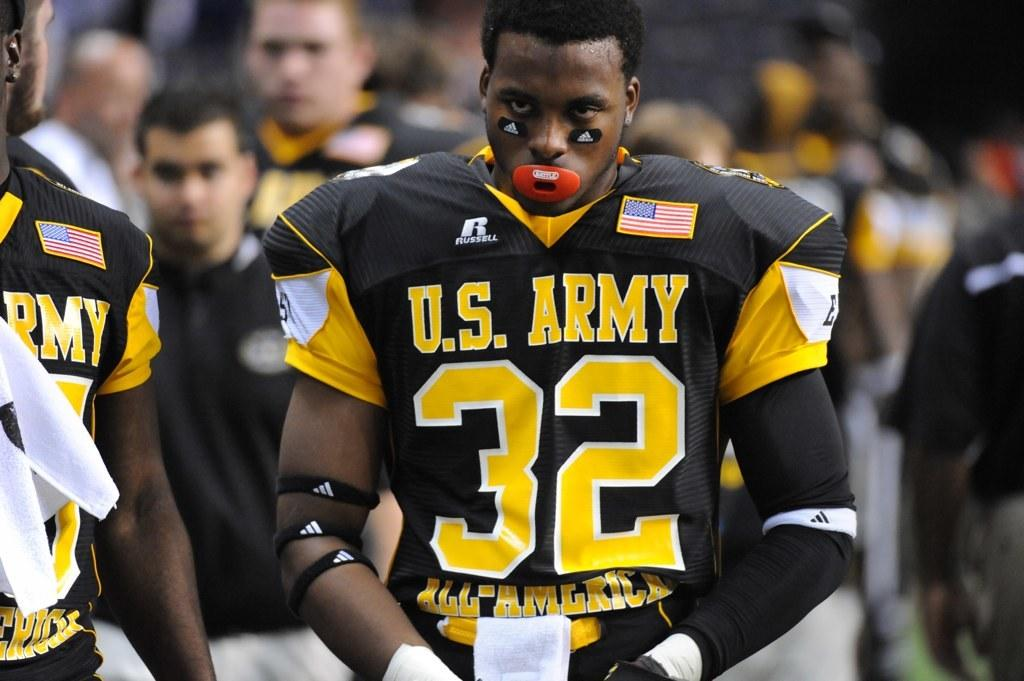Who or what is the main subject of the image? There is a person in the image. What is the person wearing? The person is wearing a black and yellow jersey. Can you describe the background of the image? There are a few people in the background of the image. What type of table is visible in the image? There is no table present in the image. How many books can be seen on the table in the image? There is no table or books present in the image. 